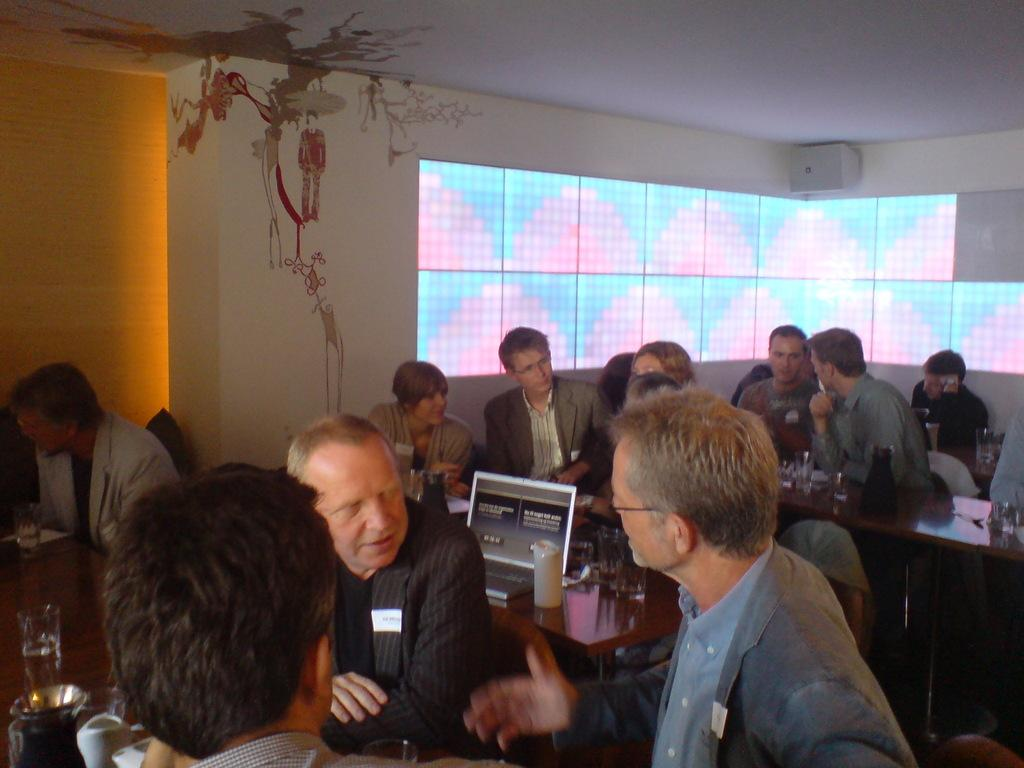How many people are in the image? There is a group of people in the image. Where are the people located in the image? The people are seated in a room. What electronic device is visible in the image? There is a laptop in the image. What piece of furniture is present in the image? There is a table in the image. What type of dishware is present in the image? There are glasses in the image. What type of chicken can be seen walking on the land in the image? There is no chicken or land present in the image. What smell can be detected in the image? The image does not provide any information about smells. 